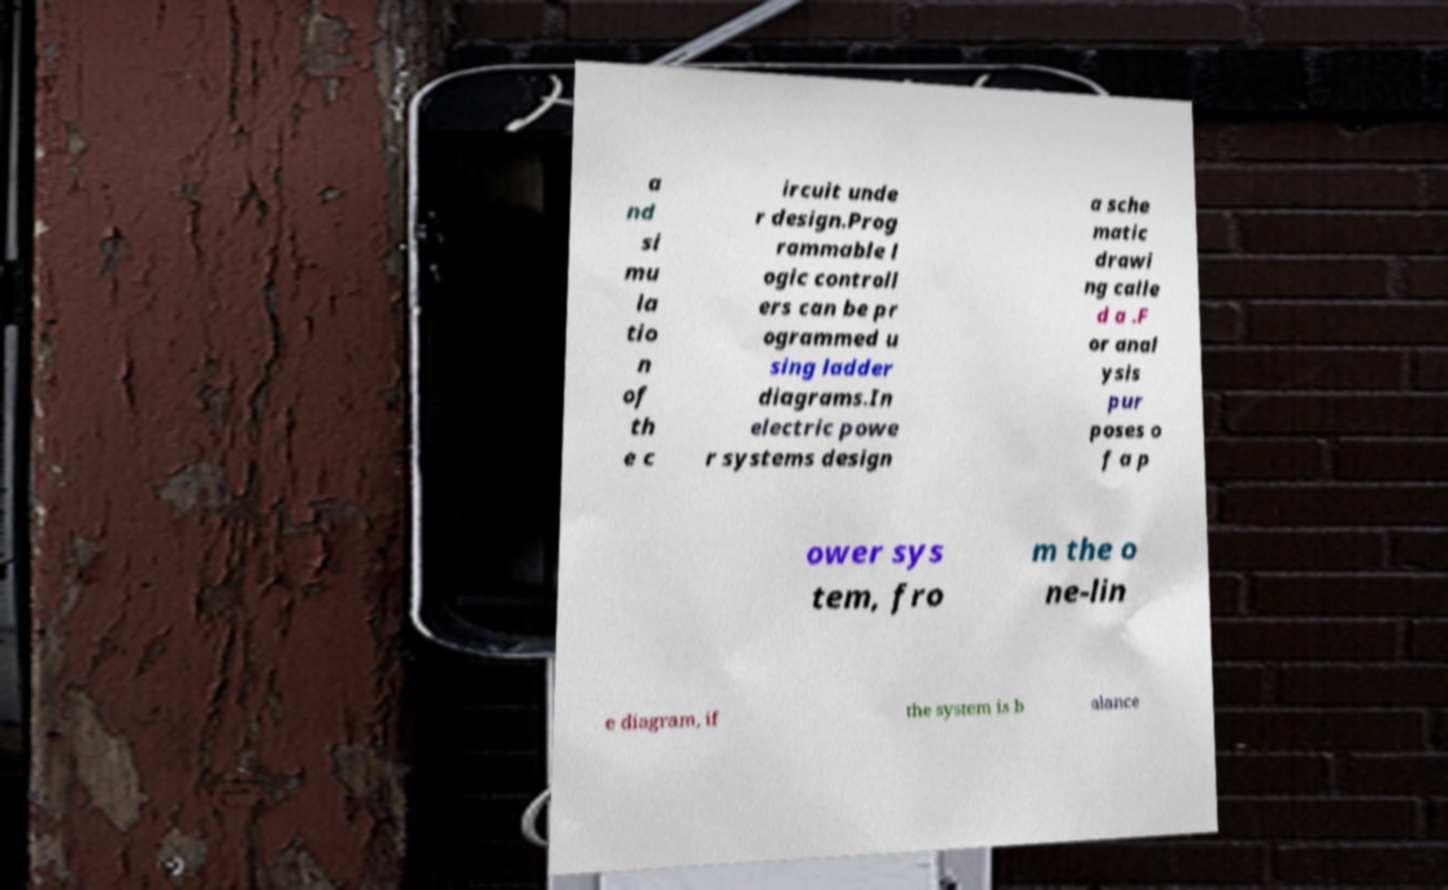Please read and relay the text visible in this image. What does it say? a nd si mu la tio n of th e c ircuit unde r design.Prog rammable l ogic controll ers can be pr ogrammed u sing ladder diagrams.In electric powe r systems design a sche matic drawi ng calle d a .F or anal ysis pur poses o f a p ower sys tem, fro m the o ne-lin e diagram, if the system is b alance 